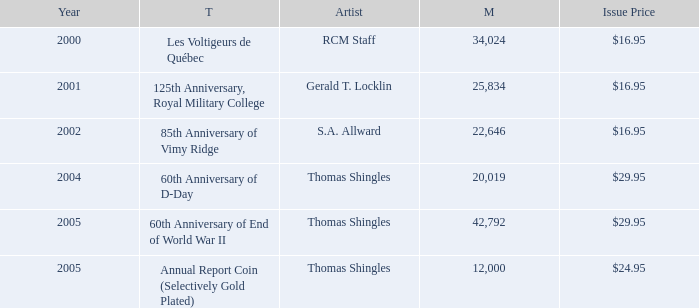What was the total mintage for years after 2002 that had a 85th Anniversary of Vimy Ridge theme? 0.0. 